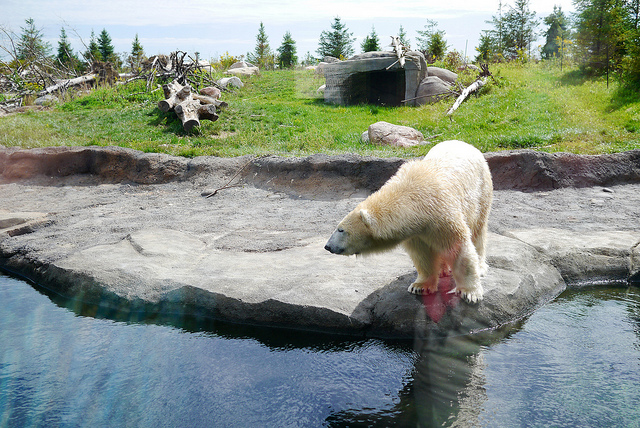How many levels doe the bus have? The image does not show a bus. It depicts a polar bear on a rocky ledge beside a body of water, possibly in an enclosure resembling a natural habitat, commonly seen in zoos or wildlife parks. 